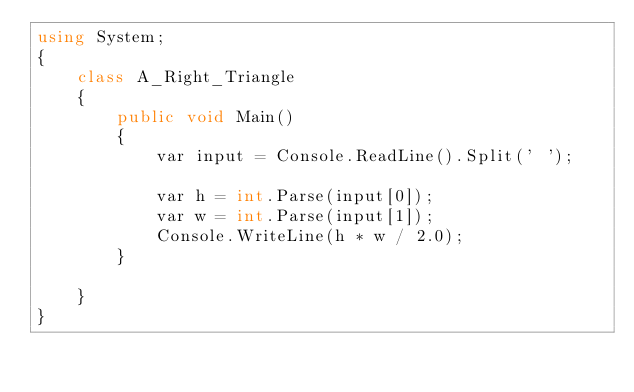Convert code to text. <code><loc_0><loc_0><loc_500><loc_500><_C#_>using System;
{
    class A_Right_Triangle
    {
        public void Main()
        {
            var input = Console.ReadLine().Split(' ');

            var h = int.Parse(input[0]);
            var w = int.Parse(input[1]);
            Console.WriteLine(h * w / 2.0);
        }

    }
}
</code> 